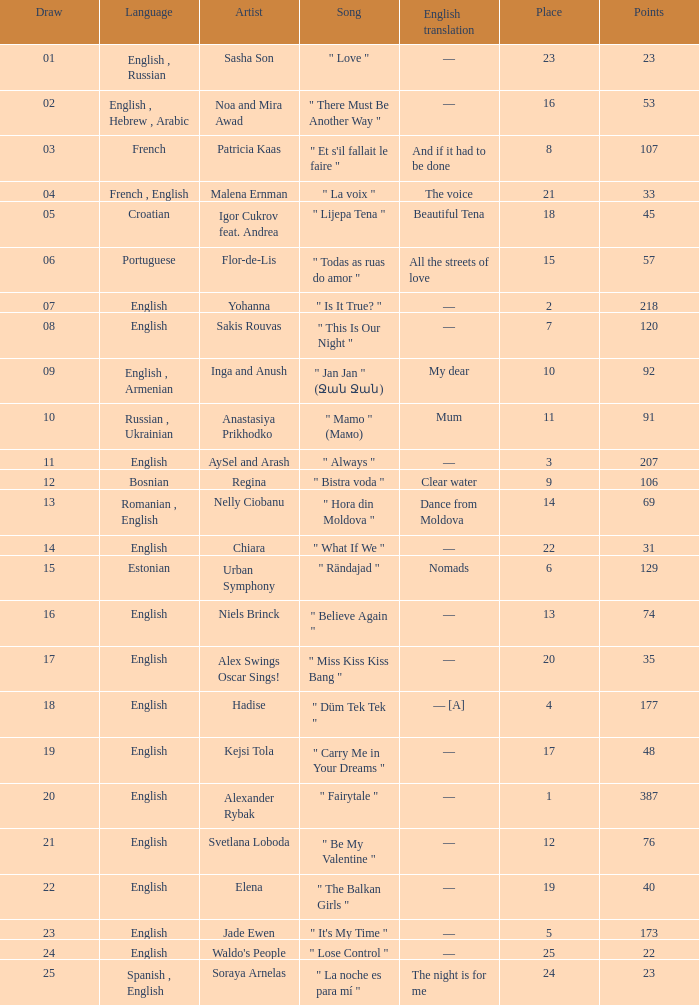What was the english translation for the song by svetlana loboda? —. 